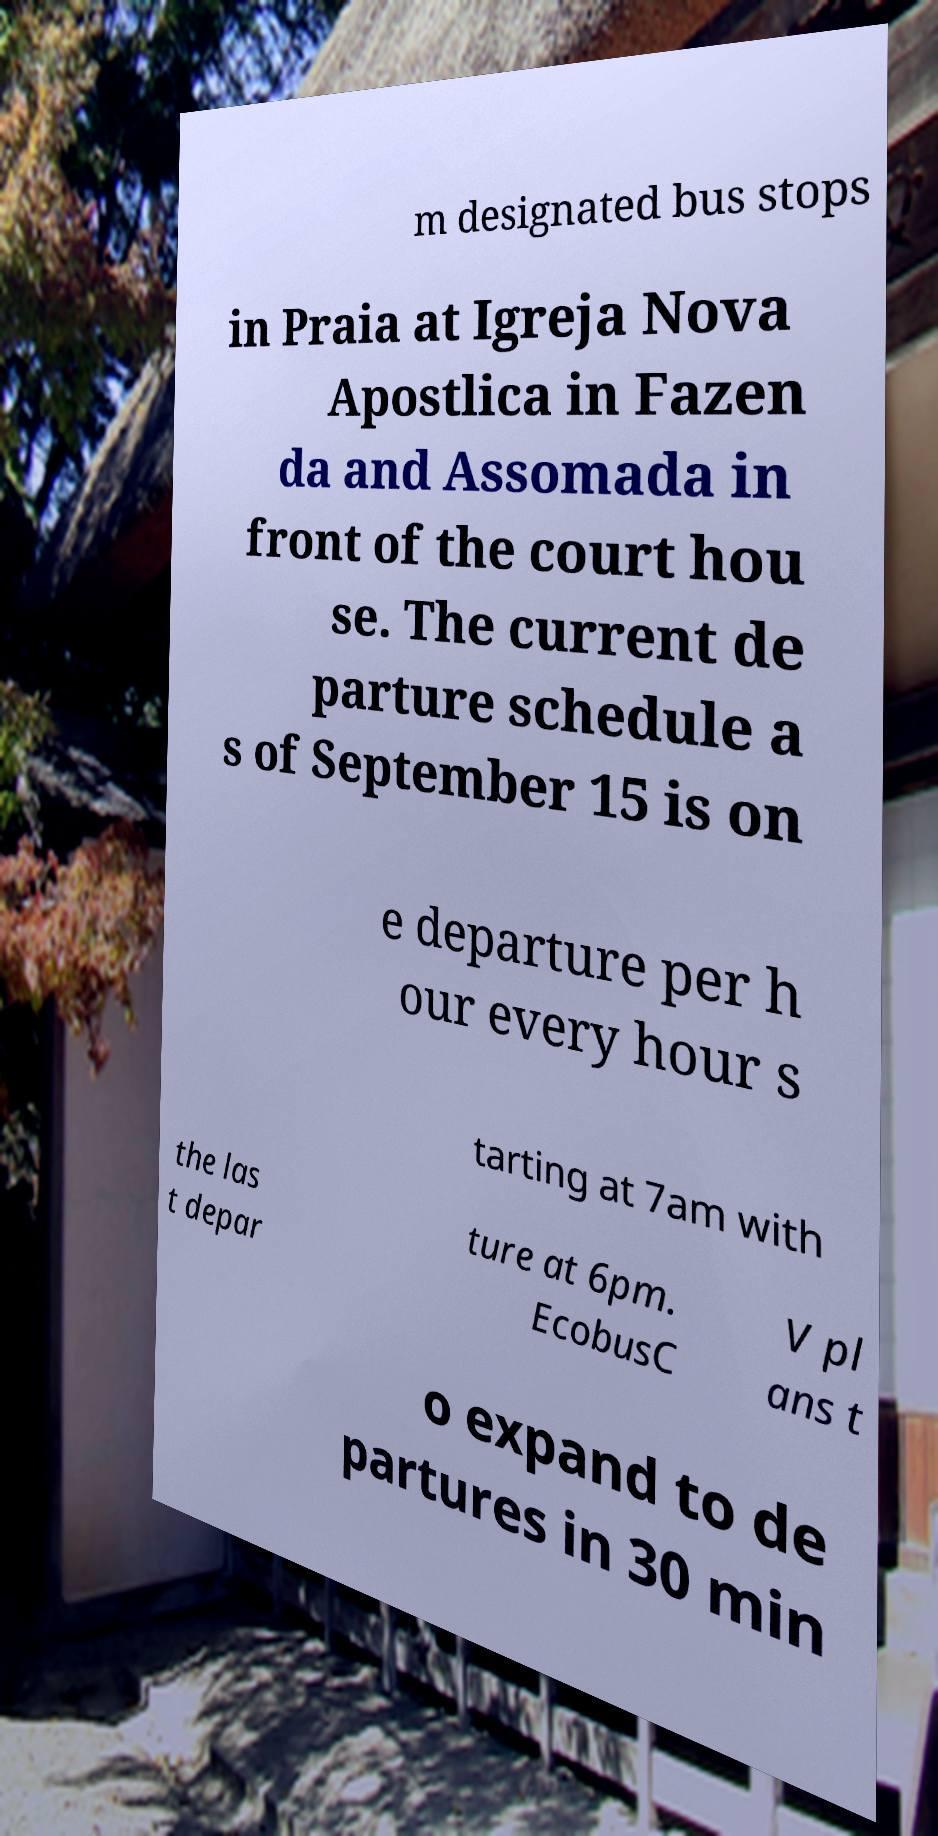Can you accurately transcribe the text from the provided image for me? m designated bus stops in Praia at Igreja Nova Apostlica in Fazen da and Assomada in front of the court hou se. The current de parture schedule a s of September 15 is on e departure per h our every hour s tarting at 7am with the las t depar ture at 6pm. EcobusC V pl ans t o expand to de partures in 30 min 